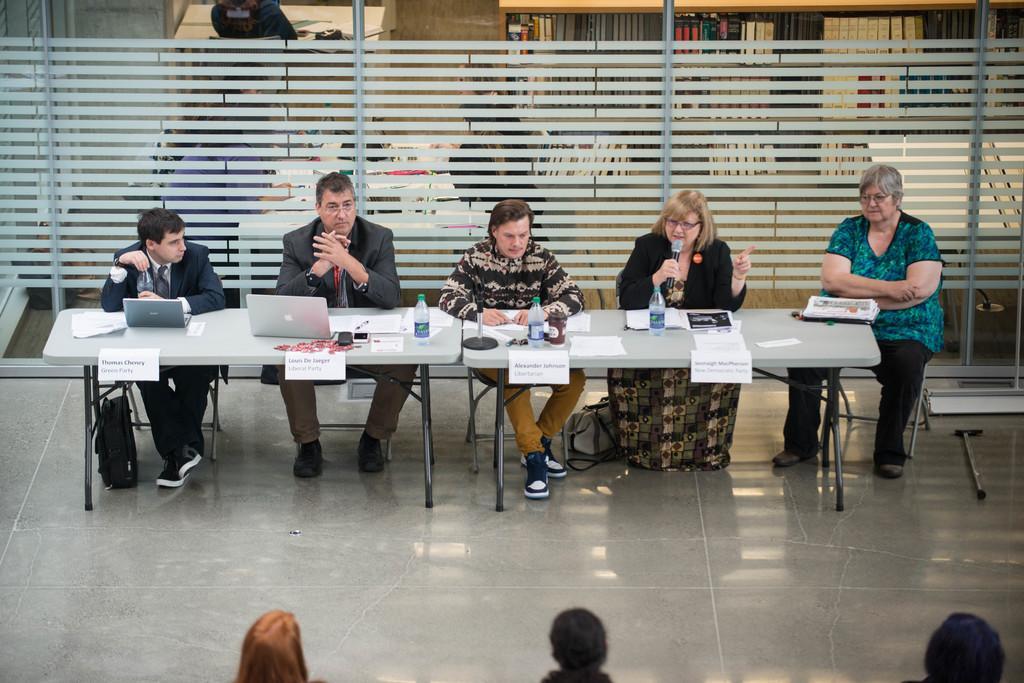Can you describe this image briefly? In this picture there are people sitting on chairs, among them there is a woman holding a microphone and we can see laptops, papers, stand, bottles and mobiles on tables and floor. In the background of the image we can see glass, through glass we can see people and books in racks. At the bottom of the image we can see heads of people. 